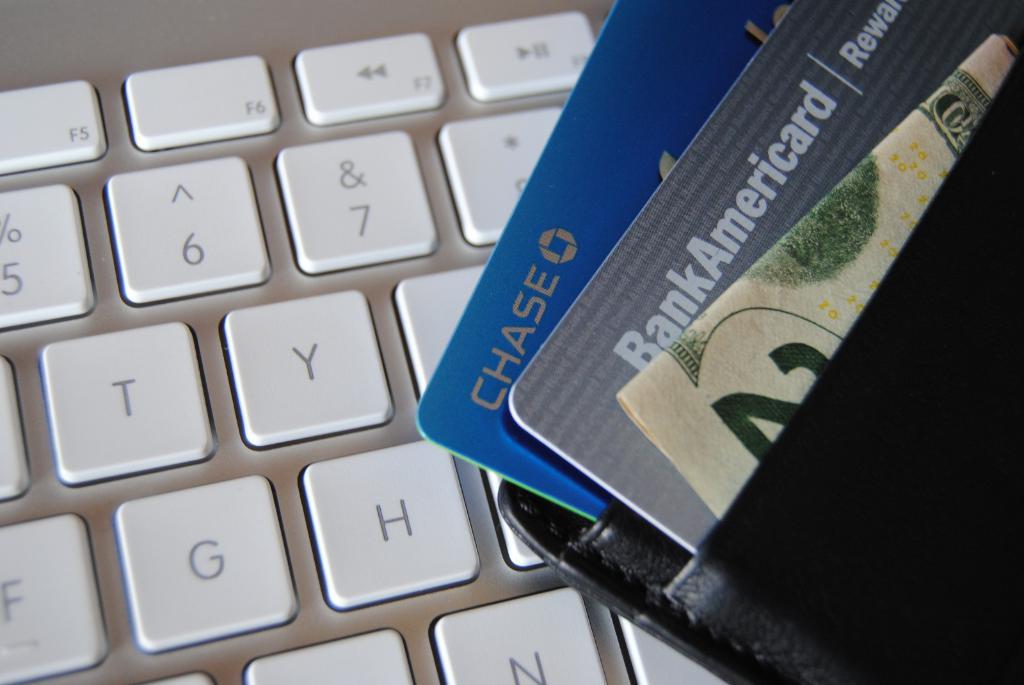What credit card is blue?
Your answer should be compact. Chase. What company issued the grey card?
Your response must be concise. Bank of america. 